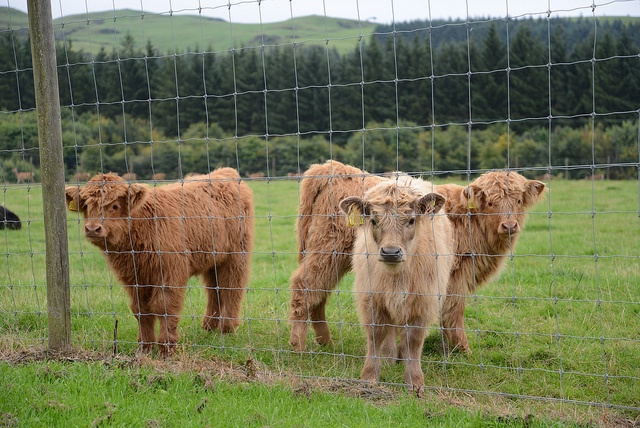Describe the objects in this image and their specific colors. I can see cow in lavender, gray, maroon, and brown tones, cow in lavender, gray, maroon, and tan tones, cow in lavender, gray, tan, and darkgray tones, and cow in lavender, black, gray, darkgreen, and olive tones in this image. 